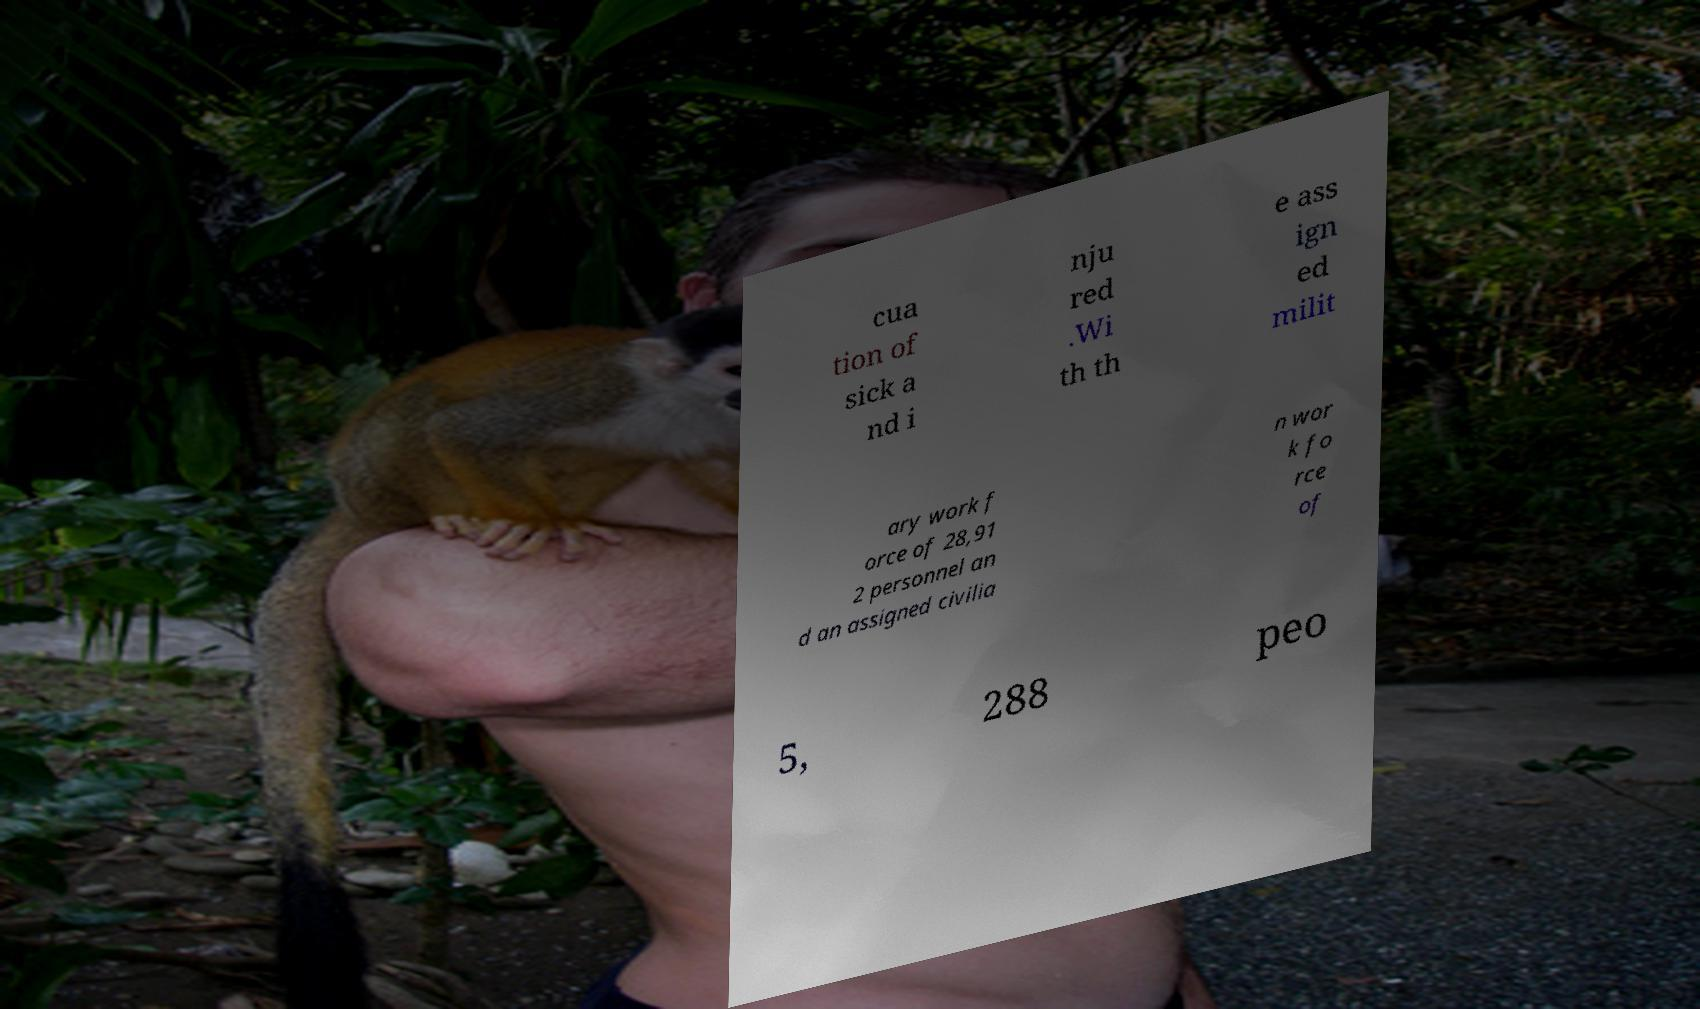There's text embedded in this image that I need extracted. Can you transcribe it verbatim? cua tion of sick a nd i nju red .Wi th th e ass ign ed milit ary work f orce of 28,91 2 personnel an d an assigned civilia n wor k fo rce of 5, 288 peo 